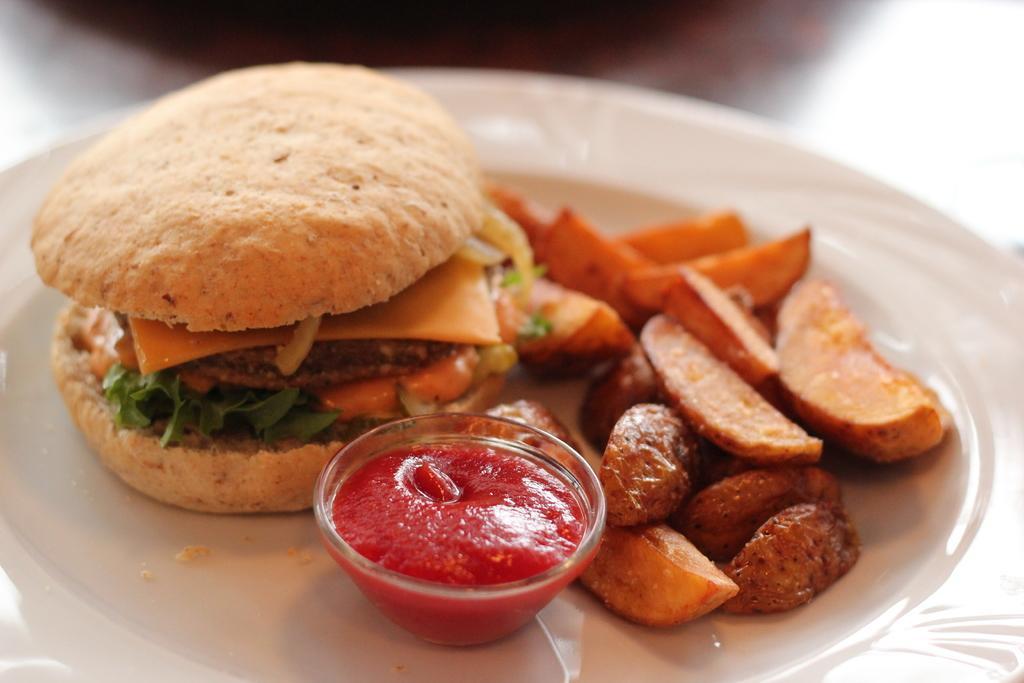Please provide a concise description of this image. In the picture there is a table, on the table there is a plate with the food item present, on the plate there is a bowl with the food item present. 